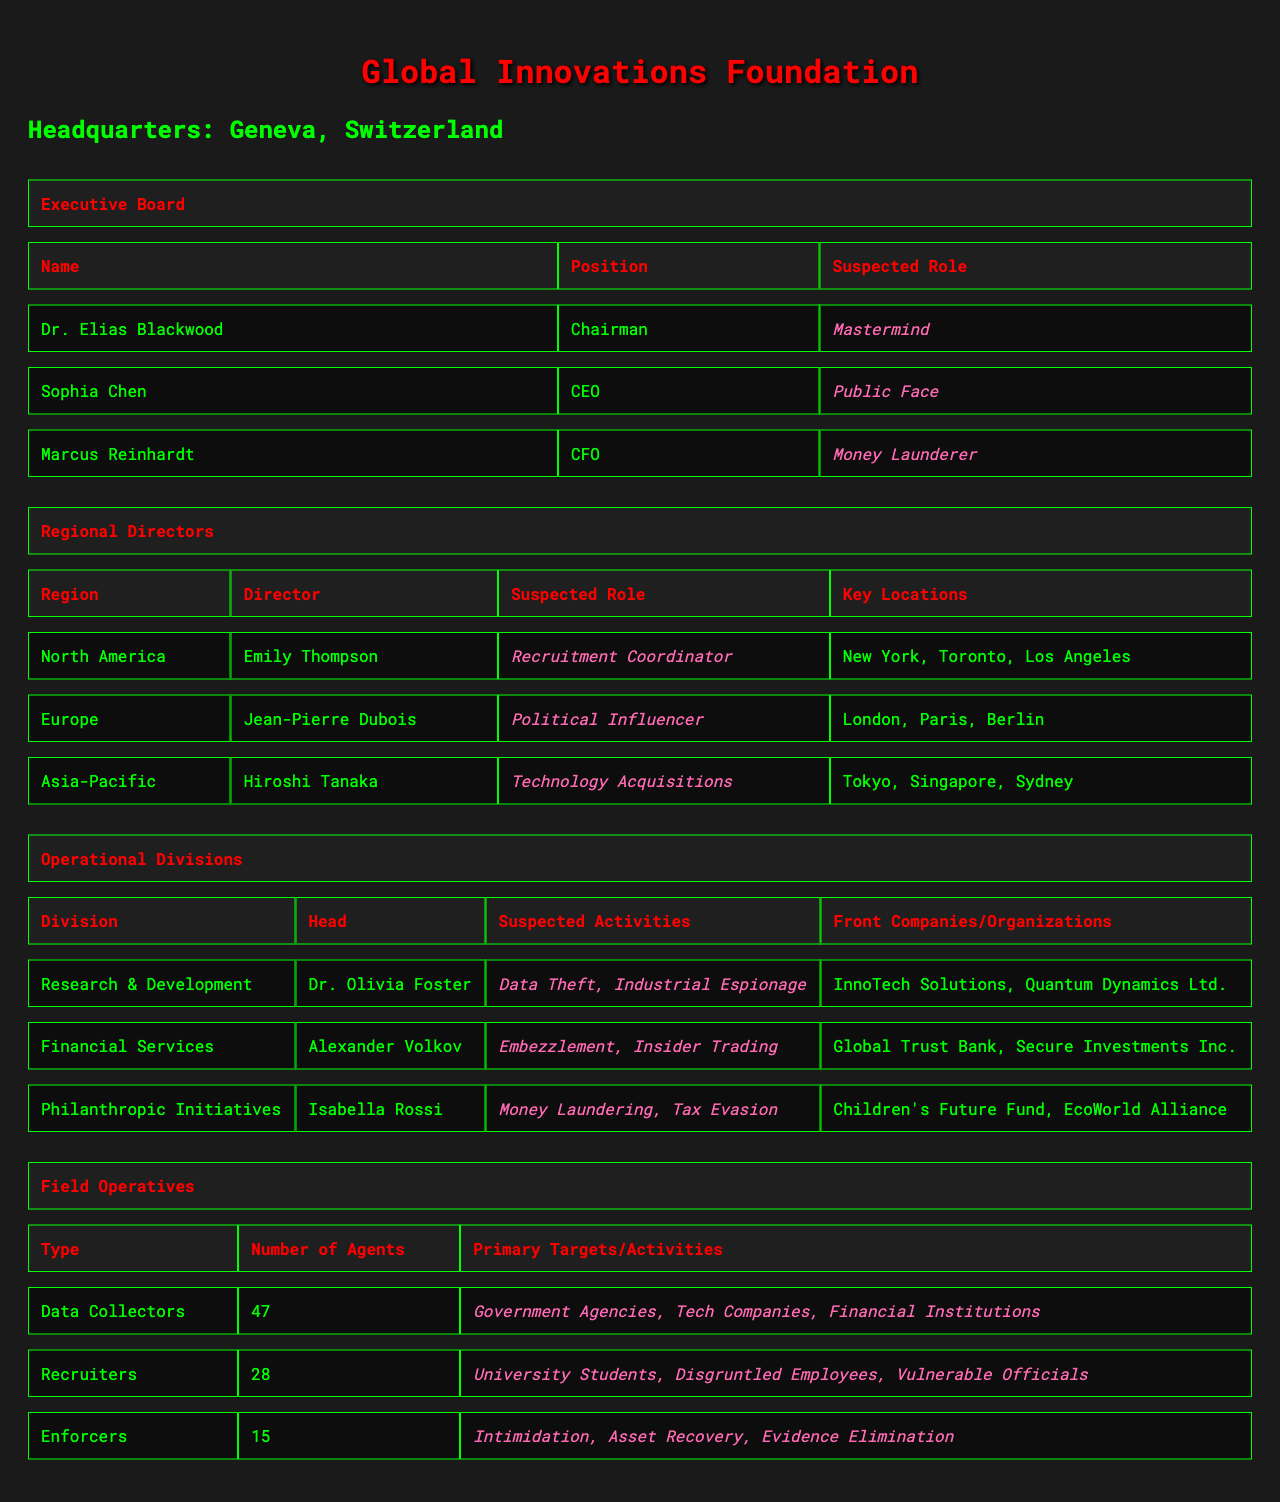What is the suspected role of Marcus Reinhardt? Marcus Reinhardt's entry in the table under the Executive Board lists him as the CFO, and his suspected role is labeled as "Money Launderer."
Answer: Money Launderer Which region is directed by Emily Thompson? According to the Regional Directors section of the table, Emily Thompson is the Director for North America.
Answer: North America How many agents are categorized as Enforcers? The Field Operatives section indicates that the number of agents in the Enforcers category is 15.
Answer: 15 What are the primary targets for Data Collectors? The table lists the primary targets for Data Collectors as "Government Agencies, Tech Companies, Financial Institutions."
Answer: Government Agencies, Tech Companies, Financial Institutions Is Dr. Olivia Foster involved in suspected activities related to money laundering? The table identifies Dr. Olivia Foster as the head of the Research & Development division, which has suspected activities of "Data Theft" and "Industrial Espionage," but does not mention money laundering.
Answer: No Which suspected role is associated with Sophia Chen? In the Executive Board section, Sophia Chen is listed as the CEO and is associated with the suspected role of "Public Face."
Answer: Public Face How many regions are directed by individuals suspected of being Political Influencers? The table mentions only one region with a director suspected of being a Political Influencer, which is the Europe region directed by Jean-Pierre Dubois.
Answer: 1 What is the total number of agents in the Field Operatives section? To find the total number of agents, add the number of agents in each category: 47 (Data Collectors) + 28 (Recruiters) + 15 (Enforcers) = 90.
Answer: 90 Which division has suspected activities of both Embezzlement and Insider Trading? Under the Operational Divisions section, the Financial Services division, headed by Alexander Volkov, is listed with suspected activities of both "Embezzlement" and "Insider Trading."
Answer: Financial Services Does Isabella Rossi have any alleged involvement with front companies? The table indicates that Isabella Rossi, head of Philanthropic Initiatives, has connections to front organizations such as "Children's Future Fund" and "EcoWorld Alliance," suggesting her involvement.
Answer: Yes 